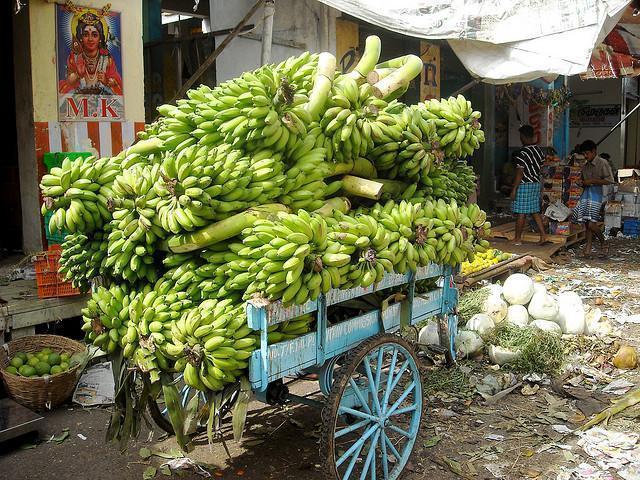What religion is common in this area?
Select the accurate response from the four choices given to answer the question.
Options: Christianity, judaism, islam, hinduism. Hinduism. 